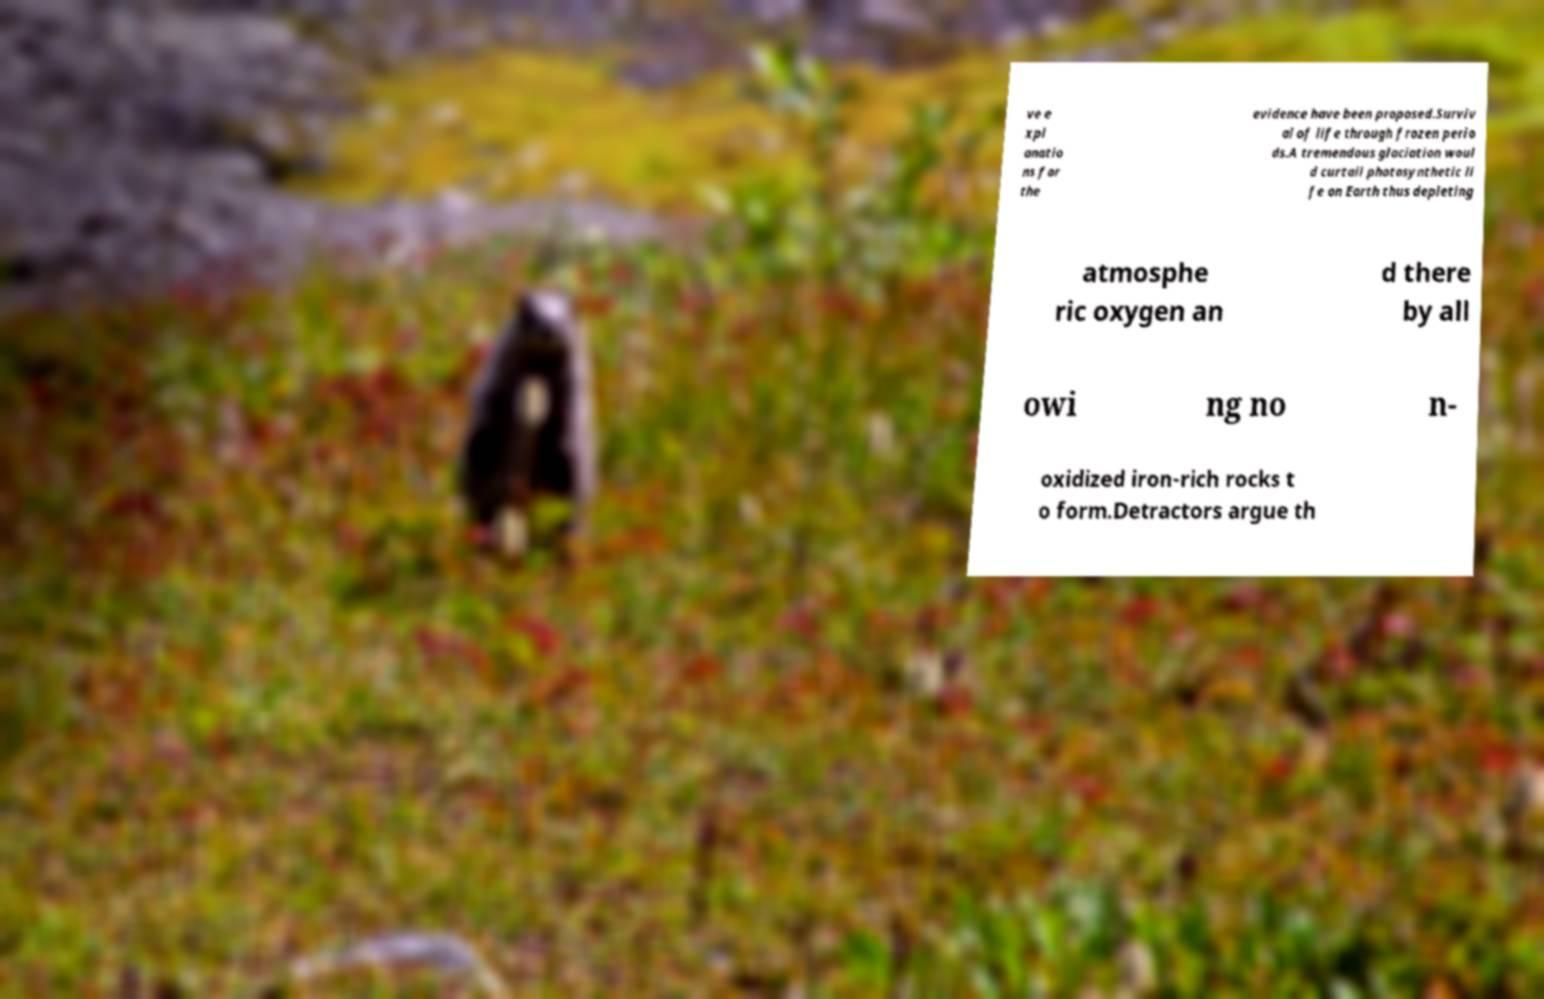Can you read and provide the text displayed in the image?This photo seems to have some interesting text. Can you extract and type it out for me? ve e xpl anatio ns for the evidence have been proposed.Surviv al of life through frozen perio ds.A tremendous glaciation woul d curtail photosynthetic li fe on Earth thus depleting atmosphe ric oxygen an d there by all owi ng no n- oxidized iron-rich rocks t o form.Detractors argue th 